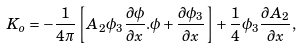Convert formula to latex. <formula><loc_0><loc_0><loc_500><loc_500>K _ { o } = - \frac { 1 } { 4 \pi } \left [ A _ { 2 } \phi _ { 3 } \frac { \partial \phi } { \partial x } . \phi + \frac { \partial \phi _ { 3 } } { \partial x } \right ] + \frac { 1 } { 4 } \phi _ { 3 } \frac { \partial A _ { 2 } } { \partial x } ,</formula> 